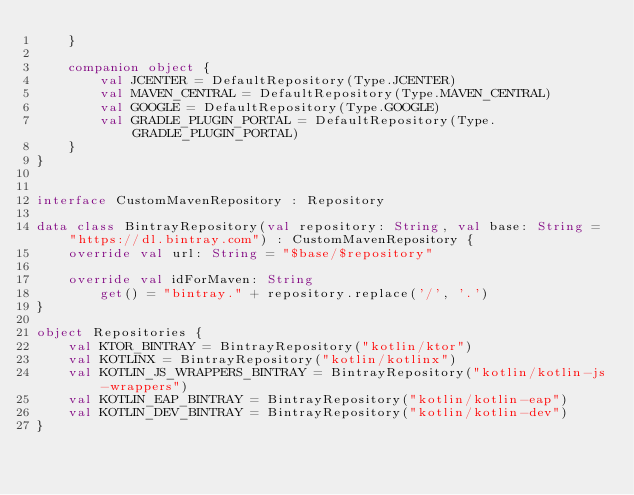<code> <loc_0><loc_0><loc_500><loc_500><_Kotlin_>    }

    companion object {
        val JCENTER = DefaultRepository(Type.JCENTER)
        val MAVEN_CENTRAL = DefaultRepository(Type.MAVEN_CENTRAL)
        val GOOGLE = DefaultRepository(Type.GOOGLE)
        val GRADLE_PLUGIN_PORTAL = DefaultRepository(Type.GRADLE_PLUGIN_PORTAL)
    }
}


interface CustomMavenRepository : Repository

data class BintrayRepository(val repository: String, val base: String = "https://dl.bintray.com") : CustomMavenRepository {
    override val url: String = "$base/$repository"

    override val idForMaven: String
        get() = "bintray." + repository.replace('/', '.')
}

object Repositories {
    val KTOR_BINTRAY = BintrayRepository("kotlin/ktor")
    val KOTLINX = BintrayRepository("kotlin/kotlinx")
    val KOTLIN_JS_WRAPPERS_BINTRAY = BintrayRepository("kotlin/kotlin-js-wrappers")
    val KOTLIN_EAP_BINTRAY = BintrayRepository("kotlin/kotlin-eap")
    val KOTLIN_DEV_BINTRAY = BintrayRepository("kotlin/kotlin-dev")
}
</code> 